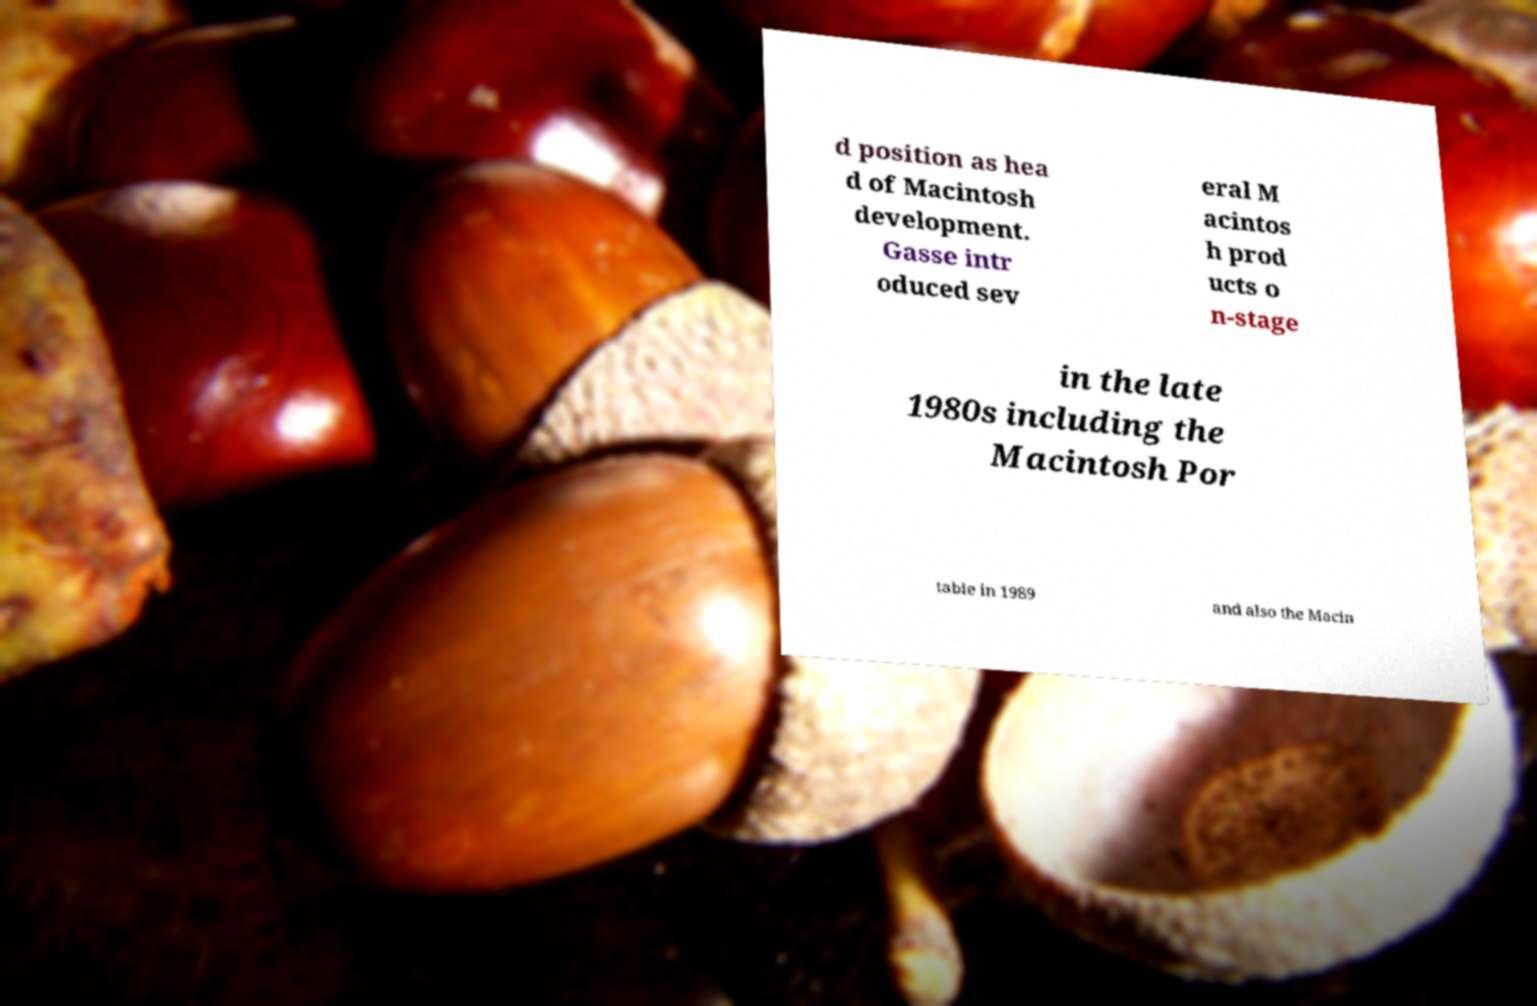What messages or text are displayed in this image? I need them in a readable, typed format. d position as hea d of Macintosh development. Gasse intr oduced sev eral M acintos h prod ucts o n-stage in the late 1980s including the Macintosh Por table in 1989 and also the Macin 